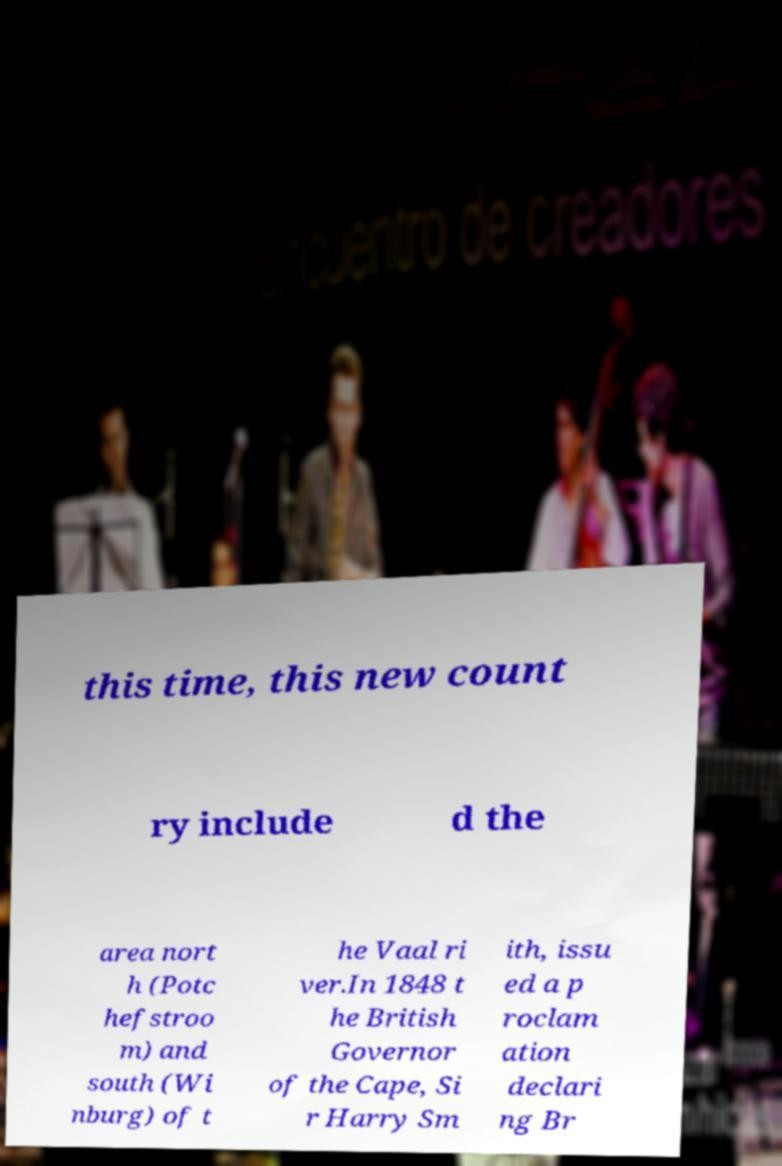Could you extract and type out the text from this image? this time, this new count ry include d the area nort h (Potc hefstroo m) and south (Wi nburg) of t he Vaal ri ver.In 1848 t he British Governor of the Cape, Si r Harry Sm ith, issu ed a p roclam ation declari ng Br 